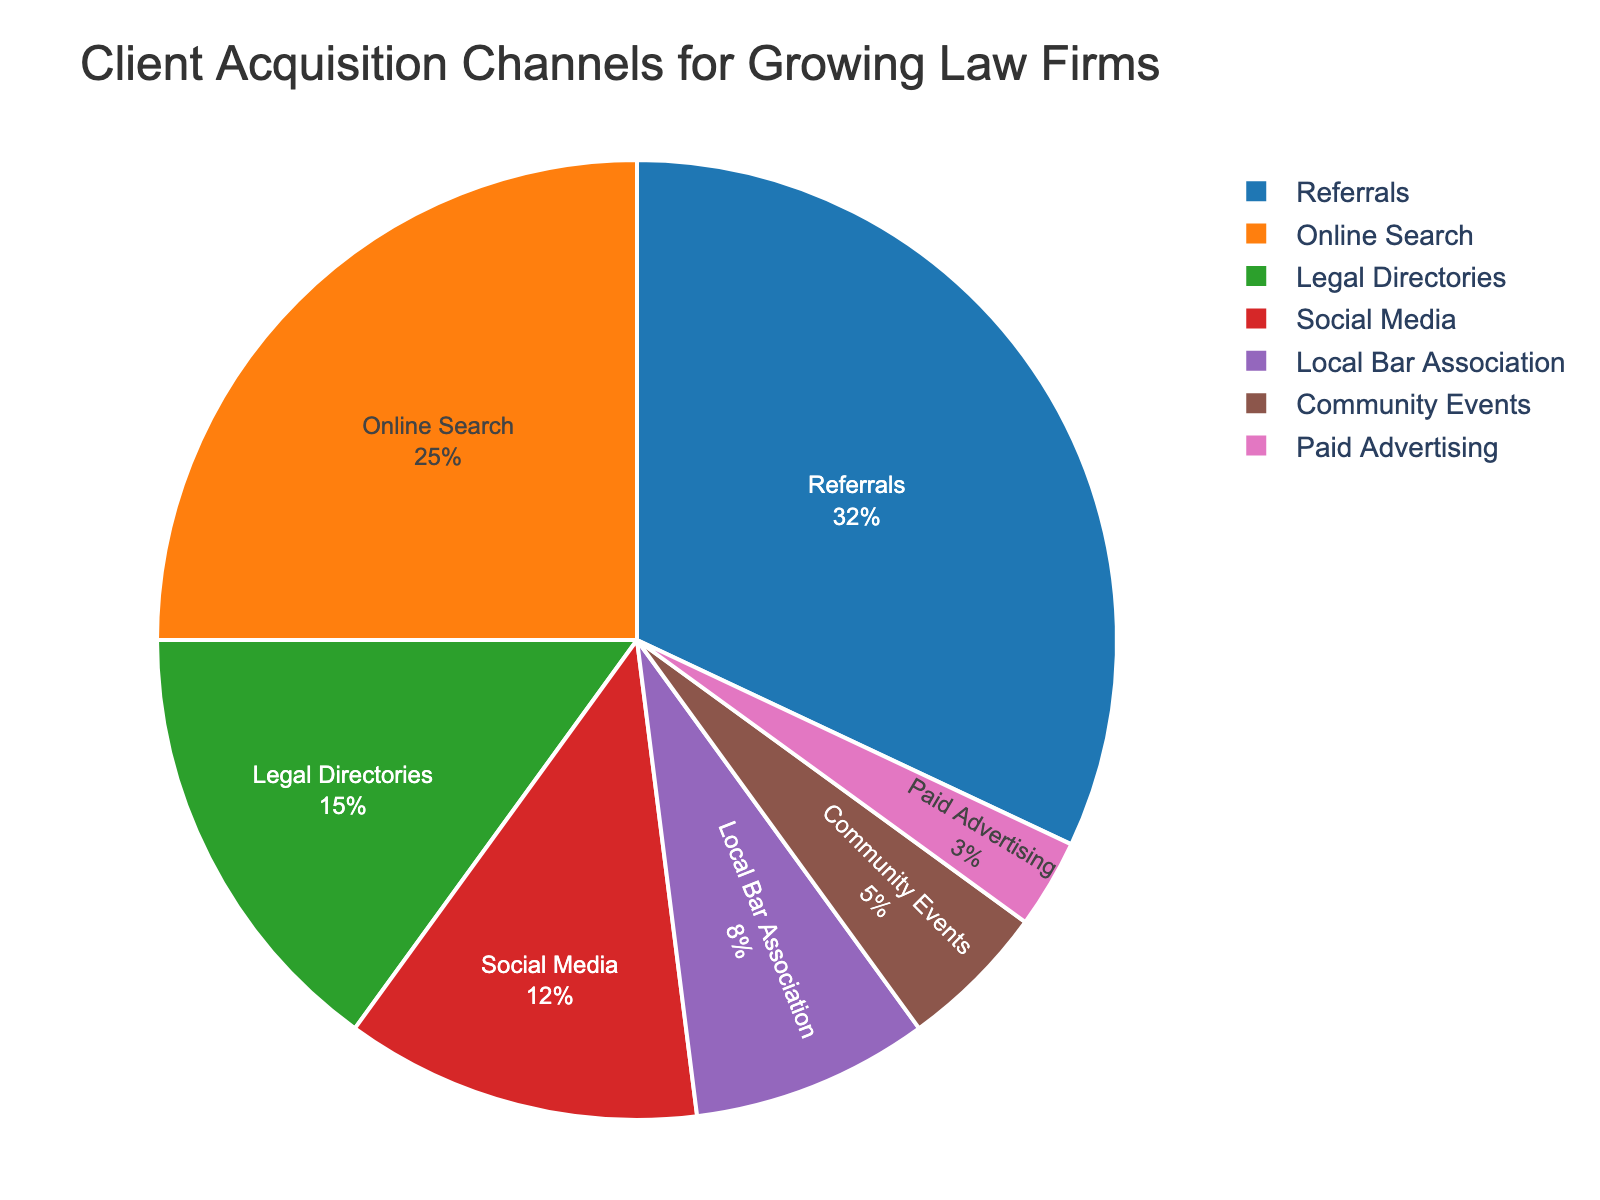what channel has the highest percentage for client acquisition? The channel with the highest percentage is visually identified by comparing the size of the pie slices. The largest slice represents the channel with the highest percentage.
Answer: Referrals what percentage of client acquisitions come from online sources (Online Search and Social Media)? Sum the percentages of Online Search (25%) and Social Media (12%): 25% + 12% = 37%.
Answer: 37% which is more effective: Legal Directories or Local Bar Association? Compare the percentages of Legal Directories (15%) and Local Bar Association (8%). Legal Directories have a higher percentage.
Answer: Legal Directories what is the combined percentage of Referrals, Legal Directories, and Local Bar Association? Sum the percentages of Referrals (32%), Legal Directories (15%), and Local Bar Association (8%): 32% + 15% + 8% = 55%.
Answer: 55% which channels contribute to more than 10% of client acquisitions? Identify the channels with percentages greater than 10%: Referrals (32%), Online Search (25%), Legal Directories (15%), and Social Media (12%).
Answer: Referrals, Online Search, Legal Directories, Social Media what are the three least effective channels for client acquisition? Identify the channels with the smallest percentages: Community Events (5%), Paid Advertising (3%), and Local Bar Association (8%).
Answer: Paid Advertising, Community Events, Local Bar Association by what percentage does Social Media exceed Paid Advertising? Subtract the percentage of Paid Advertising (3%) from Social Media (12%): 12% - 3% = 9%.
Answer: 9% what is the ratio of Referrals to Paid Advertising in client acquisition? Divide the percentage of Referrals (32%) by Paid Advertising (3%): 32 / 3 = ~10.67.
Answer: ~10.67 how does Community Events compare with Social Media in contributing to client acquisitions? Compare the percentages of Community Events (5%) and Social Media (12%). Social Media has more than double the percentage of Community Events.
Answer: Social Media has more than double Community Events 